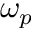Convert formula to latex. <formula><loc_0><loc_0><loc_500><loc_500>\omega _ { p }</formula> 